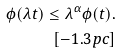Convert formula to latex. <formula><loc_0><loc_0><loc_500><loc_500>\phi ( \lambda t ) \leq \lambda ^ { \alpha } \phi ( t ) . \\ [ - 1 . 3 p c ]</formula> 